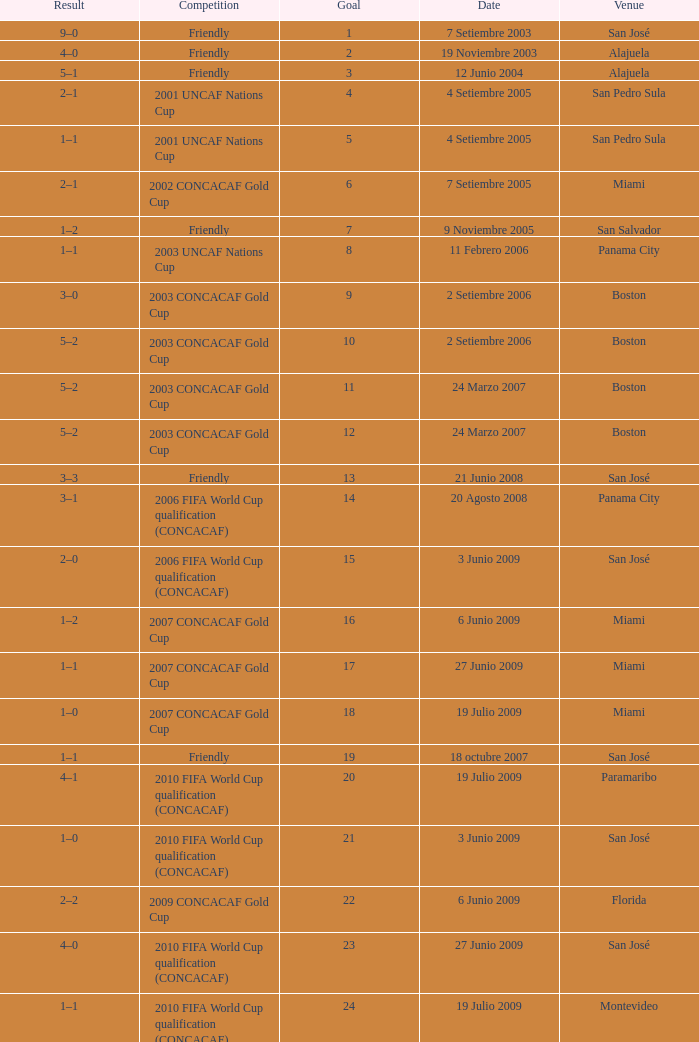How was the competition in which 6 goals were made? 2002 CONCACAF Gold Cup. 